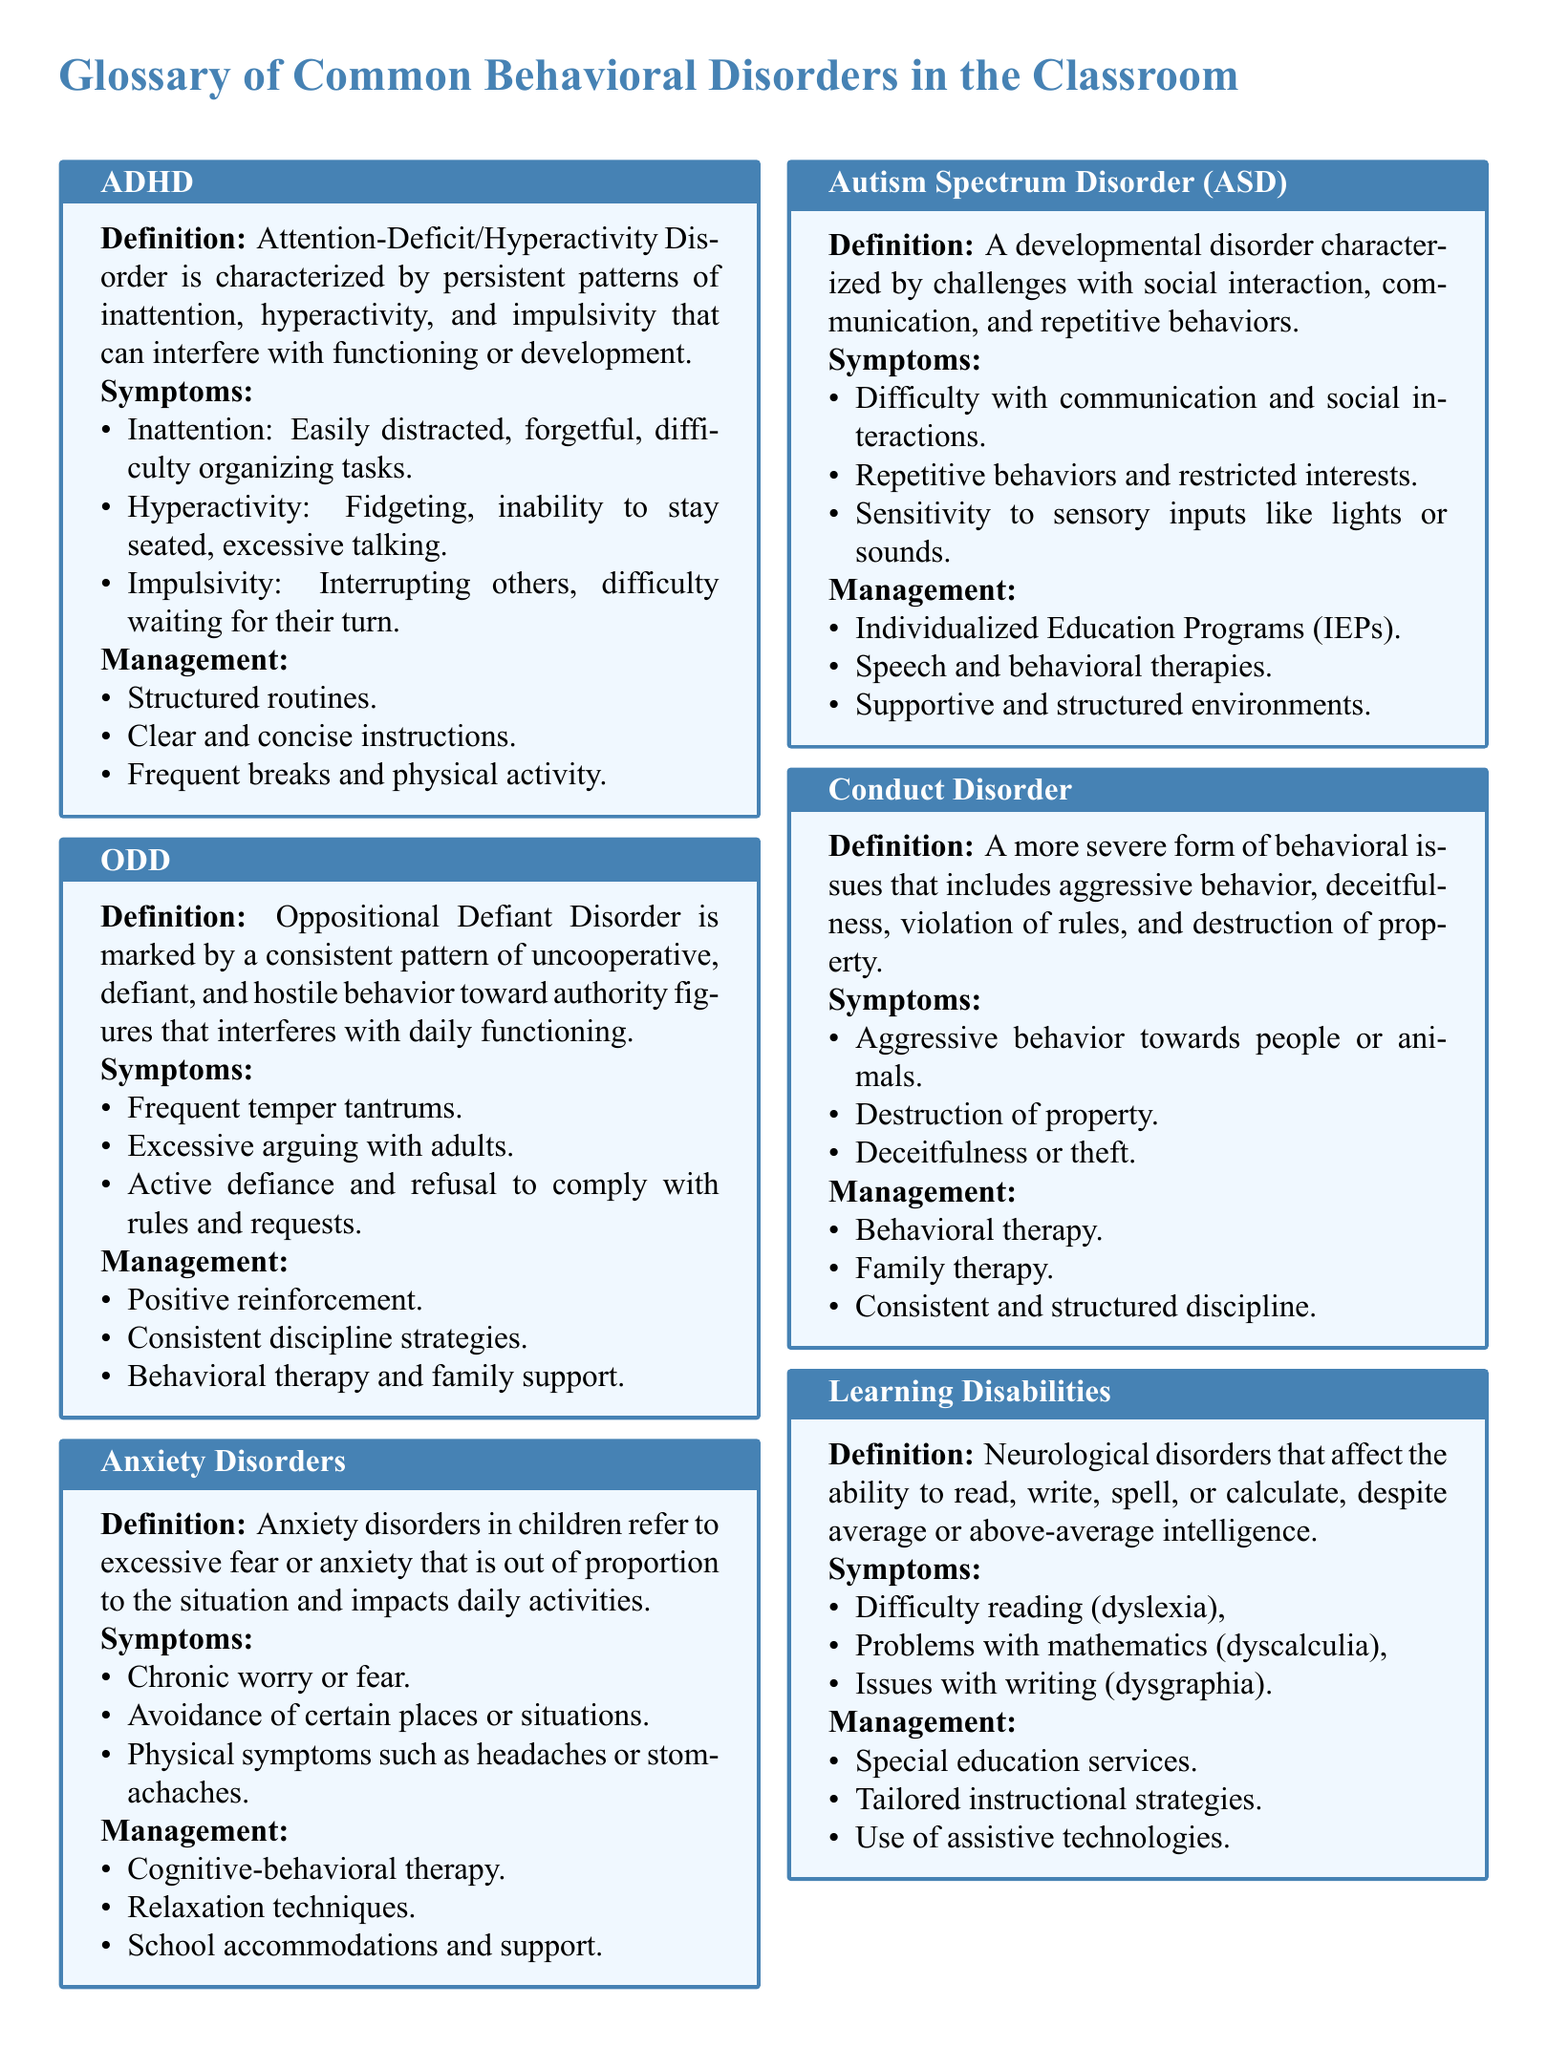What is the definition of ADHD? ADHD is characterized by persistent patterns of inattention, hyperactivity, and impulsivity that can interfere with functioning or development.
Answer: Attention-Deficit/Hyperactivity Disorder is characterized by persistent patterns of inattention, hyperactivity, and impulsivity that can interfere with functioning or development What are two symptoms of ODD? The document lists several symptoms of ODD; two specific symptoms can be extracted.
Answer: Frequent temper tantrums, Excessive arguing with adults What management strategy is suggested for Anxiety Disorders? The document outlines management strategies for Anxiety Disorders. One of these strategies can be identified.
Answer: Cognitive-behavioral therapy How many behavioral disorders are listed in the glossary? The document presents multiple behavioral disorders, enumerating them for clarity. The total can be counted.
Answer: Six Which disorder is associated with difficulty reading? The document specifies certain neurological disorders related to challenges in reading, writing, or math. The specific disorder for reading challenges can be identified.
Answer: Learning Disabilities What type of environment is recommended for children with Autism Spectrum Disorder? The document suggests a type of setting that supports children with Autism Spectrum Disorder, which can be pinpointed.
Answer: Supportive and structured environments What is a common symptom of Conduct Disorder? The document lists various symptoms associated with Conduct Disorder, and highlighting one can address the question.
Answer: Aggressive behavior towards people or animals What is the abbreviation for Oppositional Defiant Disorder? The document provides a full term for the disorder, and finding the abbreviation corresponds to the question.
Answer: ODD 